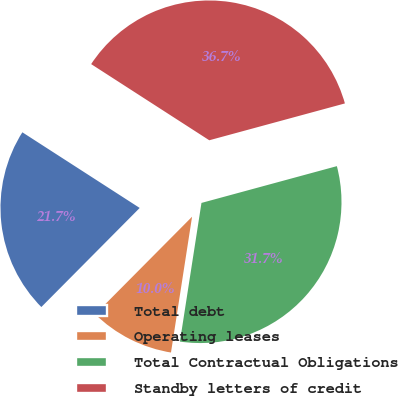Convert chart to OTSL. <chart><loc_0><loc_0><loc_500><loc_500><pie_chart><fcel>Total debt<fcel>Operating leases<fcel>Total Contractual Obligations<fcel>Standby letters of credit<nl><fcel>21.67%<fcel>9.99%<fcel>31.67%<fcel>36.66%<nl></chart> 